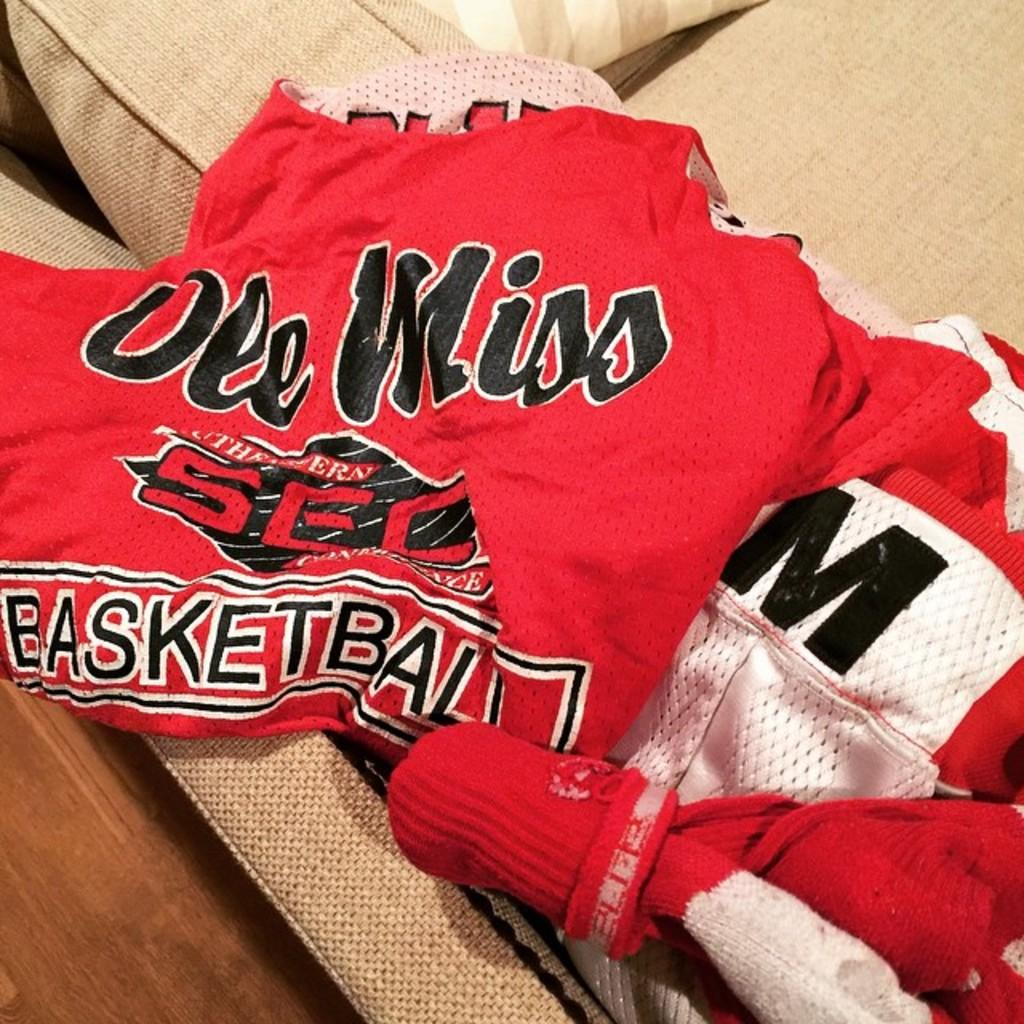What is on the couch in the foreground of the image? There are three red T-shirts on a couch in the foreground of the image. Is there anything placed on top of the T-shirts? Yes, there is a pillow on top of the T-shirts. What can be seen in the background of the image? There is a curtain visible in the image. How many lizards can be seen crawling on the T-shirts in the image? There are no lizards present in the image; it only features three red T-shirts and a pillow on a couch. 